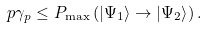<formula> <loc_0><loc_0><loc_500><loc_500>p \gamma _ { p } \leq P _ { \max } \left ( \left | \Psi _ { 1 } \right \rangle \rightarrow \left | \Psi _ { 2 } \right \rangle \right ) .</formula> 